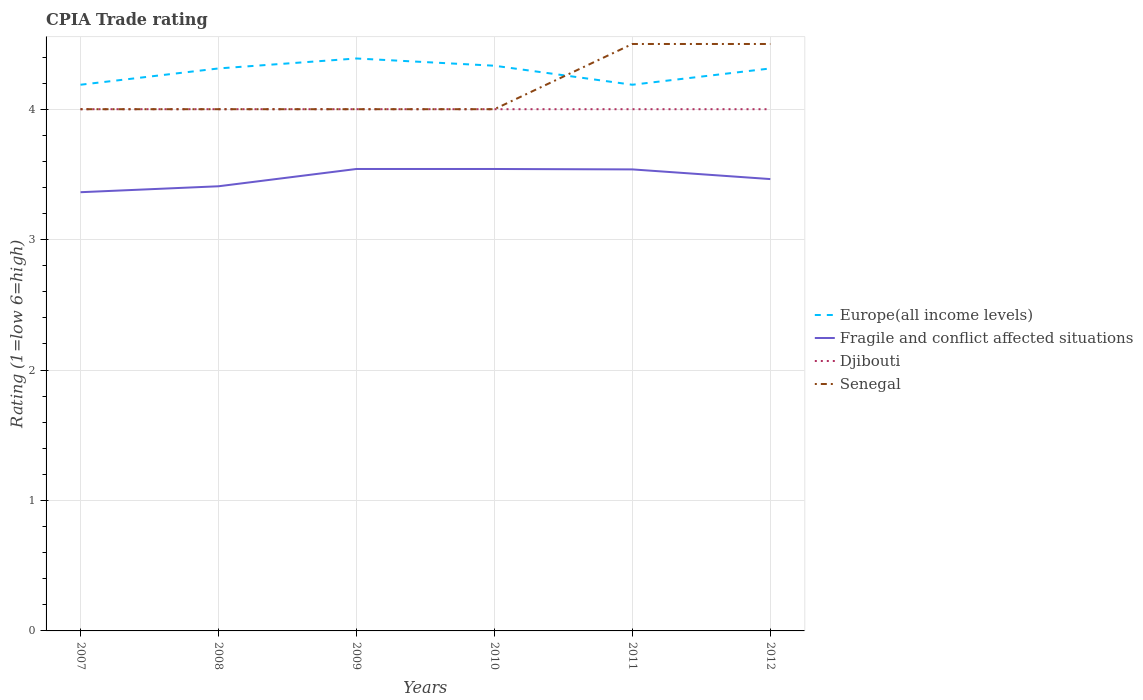How many different coloured lines are there?
Keep it short and to the point. 4. Does the line corresponding to Europe(all income levels) intersect with the line corresponding to Fragile and conflict affected situations?
Ensure brevity in your answer.  No. Is the number of lines equal to the number of legend labels?
Give a very brief answer. Yes. Across all years, what is the maximum CPIA rating in Europe(all income levels)?
Offer a very short reply. 4.19. What is the difference between the highest and the second highest CPIA rating in Fragile and conflict affected situations?
Provide a succinct answer. 0.18. How many lines are there?
Your response must be concise. 4. What is the difference between two consecutive major ticks on the Y-axis?
Your answer should be very brief. 1. Are the values on the major ticks of Y-axis written in scientific E-notation?
Offer a terse response. No. Does the graph contain any zero values?
Your answer should be compact. No. Where does the legend appear in the graph?
Your answer should be compact. Center right. How are the legend labels stacked?
Your answer should be very brief. Vertical. What is the title of the graph?
Offer a very short reply. CPIA Trade rating. Does "Hungary" appear as one of the legend labels in the graph?
Make the answer very short. No. What is the label or title of the X-axis?
Your answer should be compact. Years. What is the Rating (1=low 6=high) of Europe(all income levels) in 2007?
Keep it short and to the point. 4.19. What is the Rating (1=low 6=high) of Fragile and conflict affected situations in 2007?
Ensure brevity in your answer.  3.36. What is the Rating (1=low 6=high) in Djibouti in 2007?
Offer a terse response. 4. What is the Rating (1=low 6=high) of Senegal in 2007?
Keep it short and to the point. 4. What is the Rating (1=low 6=high) in Europe(all income levels) in 2008?
Offer a terse response. 4.31. What is the Rating (1=low 6=high) of Fragile and conflict affected situations in 2008?
Offer a very short reply. 3.41. What is the Rating (1=low 6=high) in Djibouti in 2008?
Your answer should be compact. 4. What is the Rating (1=low 6=high) of Europe(all income levels) in 2009?
Keep it short and to the point. 4.39. What is the Rating (1=low 6=high) of Fragile and conflict affected situations in 2009?
Offer a terse response. 3.54. What is the Rating (1=low 6=high) in Djibouti in 2009?
Your answer should be very brief. 4. What is the Rating (1=low 6=high) in Senegal in 2009?
Provide a short and direct response. 4. What is the Rating (1=low 6=high) of Europe(all income levels) in 2010?
Offer a terse response. 4.33. What is the Rating (1=low 6=high) of Fragile and conflict affected situations in 2010?
Keep it short and to the point. 3.54. What is the Rating (1=low 6=high) of Senegal in 2010?
Keep it short and to the point. 4. What is the Rating (1=low 6=high) of Europe(all income levels) in 2011?
Your response must be concise. 4.19. What is the Rating (1=low 6=high) in Fragile and conflict affected situations in 2011?
Offer a very short reply. 3.54. What is the Rating (1=low 6=high) of Djibouti in 2011?
Offer a very short reply. 4. What is the Rating (1=low 6=high) in Senegal in 2011?
Your answer should be very brief. 4.5. What is the Rating (1=low 6=high) in Europe(all income levels) in 2012?
Offer a very short reply. 4.31. What is the Rating (1=low 6=high) of Fragile and conflict affected situations in 2012?
Your response must be concise. 3.46. What is the Rating (1=low 6=high) of Djibouti in 2012?
Give a very brief answer. 4. What is the Rating (1=low 6=high) of Senegal in 2012?
Provide a succinct answer. 4.5. Across all years, what is the maximum Rating (1=low 6=high) of Europe(all income levels)?
Your response must be concise. 4.39. Across all years, what is the maximum Rating (1=low 6=high) of Fragile and conflict affected situations?
Your answer should be compact. 3.54. Across all years, what is the minimum Rating (1=low 6=high) in Europe(all income levels)?
Your answer should be very brief. 4.19. Across all years, what is the minimum Rating (1=low 6=high) of Fragile and conflict affected situations?
Provide a succinct answer. 3.36. Across all years, what is the minimum Rating (1=low 6=high) in Senegal?
Provide a short and direct response. 4. What is the total Rating (1=low 6=high) of Europe(all income levels) in the graph?
Offer a terse response. 25.72. What is the total Rating (1=low 6=high) in Fragile and conflict affected situations in the graph?
Keep it short and to the point. 20.86. What is the total Rating (1=low 6=high) of Senegal in the graph?
Offer a very short reply. 25. What is the difference between the Rating (1=low 6=high) in Europe(all income levels) in 2007 and that in 2008?
Your answer should be very brief. -0.12. What is the difference between the Rating (1=low 6=high) in Fragile and conflict affected situations in 2007 and that in 2008?
Give a very brief answer. -0.05. What is the difference between the Rating (1=low 6=high) of Djibouti in 2007 and that in 2008?
Offer a very short reply. 0. What is the difference between the Rating (1=low 6=high) of Senegal in 2007 and that in 2008?
Provide a succinct answer. 0. What is the difference between the Rating (1=low 6=high) of Europe(all income levels) in 2007 and that in 2009?
Provide a succinct answer. -0.2. What is the difference between the Rating (1=low 6=high) of Fragile and conflict affected situations in 2007 and that in 2009?
Provide a short and direct response. -0.18. What is the difference between the Rating (1=low 6=high) in Senegal in 2007 and that in 2009?
Offer a terse response. 0. What is the difference between the Rating (1=low 6=high) in Europe(all income levels) in 2007 and that in 2010?
Keep it short and to the point. -0.15. What is the difference between the Rating (1=low 6=high) in Fragile and conflict affected situations in 2007 and that in 2010?
Give a very brief answer. -0.18. What is the difference between the Rating (1=low 6=high) of Europe(all income levels) in 2007 and that in 2011?
Offer a terse response. 0. What is the difference between the Rating (1=low 6=high) in Fragile and conflict affected situations in 2007 and that in 2011?
Offer a terse response. -0.17. What is the difference between the Rating (1=low 6=high) of Djibouti in 2007 and that in 2011?
Your answer should be compact. 0. What is the difference between the Rating (1=low 6=high) in Europe(all income levels) in 2007 and that in 2012?
Your answer should be very brief. -0.12. What is the difference between the Rating (1=low 6=high) in Fragile and conflict affected situations in 2007 and that in 2012?
Your answer should be very brief. -0.1. What is the difference between the Rating (1=low 6=high) of Senegal in 2007 and that in 2012?
Offer a terse response. -0.5. What is the difference between the Rating (1=low 6=high) in Europe(all income levels) in 2008 and that in 2009?
Give a very brief answer. -0.08. What is the difference between the Rating (1=low 6=high) of Fragile and conflict affected situations in 2008 and that in 2009?
Offer a terse response. -0.13. What is the difference between the Rating (1=low 6=high) of Djibouti in 2008 and that in 2009?
Offer a terse response. 0. What is the difference between the Rating (1=low 6=high) in Europe(all income levels) in 2008 and that in 2010?
Make the answer very short. -0.02. What is the difference between the Rating (1=low 6=high) in Fragile and conflict affected situations in 2008 and that in 2010?
Make the answer very short. -0.13. What is the difference between the Rating (1=low 6=high) of Europe(all income levels) in 2008 and that in 2011?
Offer a very short reply. 0.12. What is the difference between the Rating (1=low 6=high) in Fragile and conflict affected situations in 2008 and that in 2011?
Offer a very short reply. -0.13. What is the difference between the Rating (1=low 6=high) of Djibouti in 2008 and that in 2011?
Provide a succinct answer. 0. What is the difference between the Rating (1=low 6=high) of Senegal in 2008 and that in 2011?
Your answer should be compact. -0.5. What is the difference between the Rating (1=low 6=high) of Fragile and conflict affected situations in 2008 and that in 2012?
Ensure brevity in your answer.  -0.06. What is the difference between the Rating (1=low 6=high) of Europe(all income levels) in 2009 and that in 2010?
Offer a very short reply. 0.06. What is the difference between the Rating (1=low 6=high) of Fragile and conflict affected situations in 2009 and that in 2010?
Your response must be concise. 0. What is the difference between the Rating (1=low 6=high) in Europe(all income levels) in 2009 and that in 2011?
Your response must be concise. 0.2. What is the difference between the Rating (1=low 6=high) in Fragile and conflict affected situations in 2009 and that in 2011?
Keep it short and to the point. 0. What is the difference between the Rating (1=low 6=high) of Djibouti in 2009 and that in 2011?
Your response must be concise. 0. What is the difference between the Rating (1=low 6=high) of Senegal in 2009 and that in 2011?
Make the answer very short. -0.5. What is the difference between the Rating (1=low 6=high) of Europe(all income levels) in 2009 and that in 2012?
Your answer should be very brief. 0.08. What is the difference between the Rating (1=low 6=high) in Fragile and conflict affected situations in 2009 and that in 2012?
Your answer should be very brief. 0.08. What is the difference between the Rating (1=low 6=high) of Senegal in 2009 and that in 2012?
Offer a terse response. -0.5. What is the difference between the Rating (1=low 6=high) of Europe(all income levels) in 2010 and that in 2011?
Offer a very short reply. 0.15. What is the difference between the Rating (1=low 6=high) in Fragile and conflict affected situations in 2010 and that in 2011?
Your response must be concise. 0. What is the difference between the Rating (1=low 6=high) in Djibouti in 2010 and that in 2011?
Ensure brevity in your answer.  0. What is the difference between the Rating (1=low 6=high) in Senegal in 2010 and that in 2011?
Your answer should be very brief. -0.5. What is the difference between the Rating (1=low 6=high) of Europe(all income levels) in 2010 and that in 2012?
Provide a succinct answer. 0.02. What is the difference between the Rating (1=low 6=high) of Fragile and conflict affected situations in 2010 and that in 2012?
Provide a short and direct response. 0.08. What is the difference between the Rating (1=low 6=high) in Senegal in 2010 and that in 2012?
Your answer should be compact. -0.5. What is the difference between the Rating (1=low 6=high) in Europe(all income levels) in 2011 and that in 2012?
Make the answer very short. -0.12. What is the difference between the Rating (1=low 6=high) of Fragile and conflict affected situations in 2011 and that in 2012?
Provide a succinct answer. 0.07. What is the difference between the Rating (1=low 6=high) in Djibouti in 2011 and that in 2012?
Give a very brief answer. 0. What is the difference between the Rating (1=low 6=high) in Senegal in 2011 and that in 2012?
Keep it short and to the point. 0. What is the difference between the Rating (1=low 6=high) in Europe(all income levels) in 2007 and the Rating (1=low 6=high) in Fragile and conflict affected situations in 2008?
Keep it short and to the point. 0.78. What is the difference between the Rating (1=low 6=high) of Europe(all income levels) in 2007 and the Rating (1=low 6=high) of Djibouti in 2008?
Offer a terse response. 0.19. What is the difference between the Rating (1=low 6=high) in Europe(all income levels) in 2007 and the Rating (1=low 6=high) in Senegal in 2008?
Keep it short and to the point. 0.19. What is the difference between the Rating (1=low 6=high) in Fragile and conflict affected situations in 2007 and the Rating (1=low 6=high) in Djibouti in 2008?
Provide a short and direct response. -0.64. What is the difference between the Rating (1=low 6=high) of Fragile and conflict affected situations in 2007 and the Rating (1=low 6=high) of Senegal in 2008?
Provide a succinct answer. -0.64. What is the difference between the Rating (1=low 6=high) of Djibouti in 2007 and the Rating (1=low 6=high) of Senegal in 2008?
Offer a terse response. 0. What is the difference between the Rating (1=low 6=high) of Europe(all income levels) in 2007 and the Rating (1=low 6=high) of Fragile and conflict affected situations in 2009?
Your answer should be very brief. 0.65. What is the difference between the Rating (1=low 6=high) of Europe(all income levels) in 2007 and the Rating (1=low 6=high) of Djibouti in 2009?
Your response must be concise. 0.19. What is the difference between the Rating (1=low 6=high) of Europe(all income levels) in 2007 and the Rating (1=low 6=high) of Senegal in 2009?
Keep it short and to the point. 0.19. What is the difference between the Rating (1=low 6=high) in Fragile and conflict affected situations in 2007 and the Rating (1=low 6=high) in Djibouti in 2009?
Your answer should be compact. -0.64. What is the difference between the Rating (1=low 6=high) in Fragile and conflict affected situations in 2007 and the Rating (1=low 6=high) in Senegal in 2009?
Ensure brevity in your answer.  -0.64. What is the difference between the Rating (1=low 6=high) of Europe(all income levels) in 2007 and the Rating (1=low 6=high) of Fragile and conflict affected situations in 2010?
Provide a succinct answer. 0.65. What is the difference between the Rating (1=low 6=high) in Europe(all income levels) in 2007 and the Rating (1=low 6=high) in Djibouti in 2010?
Your answer should be very brief. 0.19. What is the difference between the Rating (1=low 6=high) of Europe(all income levels) in 2007 and the Rating (1=low 6=high) of Senegal in 2010?
Offer a very short reply. 0.19. What is the difference between the Rating (1=low 6=high) of Fragile and conflict affected situations in 2007 and the Rating (1=low 6=high) of Djibouti in 2010?
Ensure brevity in your answer.  -0.64. What is the difference between the Rating (1=low 6=high) in Fragile and conflict affected situations in 2007 and the Rating (1=low 6=high) in Senegal in 2010?
Your answer should be very brief. -0.64. What is the difference between the Rating (1=low 6=high) in Europe(all income levels) in 2007 and the Rating (1=low 6=high) in Fragile and conflict affected situations in 2011?
Provide a short and direct response. 0.65. What is the difference between the Rating (1=low 6=high) of Europe(all income levels) in 2007 and the Rating (1=low 6=high) of Djibouti in 2011?
Give a very brief answer. 0.19. What is the difference between the Rating (1=low 6=high) of Europe(all income levels) in 2007 and the Rating (1=low 6=high) of Senegal in 2011?
Make the answer very short. -0.31. What is the difference between the Rating (1=low 6=high) of Fragile and conflict affected situations in 2007 and the Rating (1=low 6=high) of Djibouti in 2011?
Your answer should be compact. -0.64. What is the difference between the Rating (1=low 6=high) of Fragile and conflict affected situations in 2007 and the Rating (1=low 6=high) of Senegal in 2011?
Your answer should be compact. -1.14. What is the difference between the Rating (1=low 6=high) of Djibouti in 2007 and the Rating (1=low 6=high) of Senegal in 2011?
Provide a short and direct response. -0.5. What is the difference between the Rating (1=low 6=high) of Europe(all income levels) in 2007 and the Rating (1=low 6=high) of Fragile and conflict affected situations in 2012?
Offer a very short reply. 0.72. What is the difference between the Rating (1=low 6=high) in Europe(all income levels) in 2007 and the Rating (1=low 6=high) in Djibouti in 2012?
Your answer should be compact. 0.19. What is the difference between the Rating (1=low 6=high) in Europe(all income levels) in 2007 and the Rating (1=low 6=high) in Senegal in 2012?
Keep it short and to the point. -0.31. What is the difference between the Rating (1=low 6=high) in Fragile and conflict affected situations in 2007 and the Rating (1=low 6=high) in Djibouti in 2012?
Ensure brevity in your answer.  -0.64. What is the difference between the Rating (1=low 6=high) of Fragile and conflict affected situations in 2007 and the Rating (1=low 6=high) of Senegal in 2012?
Your answer should be compact. -1.14. What is the difference between the Rating (1=low 6=high) in Djibouti in 2007 and the Rating (1=low 6=high) in Senegal in 2012?
Your response must be concise. -0.5. What is the difference between the Rating (1=low 6=high) of Europe(all income levels) in 2008 and the Rating (1=low 6=high) of Fragile and conflict affected situations in 2009?
Your response must be concise. 0.77. What is the difference between the Rating (1=low 6=high) of Europe(all income levels) in 2008 and the Rating (1=low 6=high) of Djibouti in 2009?
Make the answer very short. 0.31. What is the difference between the Rating (1=low 6=high) of Europe(all income levels) in 2008 and the Rating (1=low 6=high) of Senegal in 2009?
Provide a short and direct response. 0.31. What is the difference between the Rating (1=low 6=high) of Fragile and conflict affected situations in 2008 and the Rating (1=low 6=high) of Djibouti in 2009?
Your response must be concise. -0.59. What is the difference between the Rating (1=low 6=high) of Fragile and conflict affected situations in 2008 and the Rating (1=low 6=high) of Senegal in 2009?
Keep it short and to the point. -0.59. What is the difference between the Rating (1=low 6=high) in Europe(all income levels) in 2008 and the Rating (1=low 6=high) in Fragile and conflict affected situations in 2010?
Your answer should be compact. 0.77. What is the difference between the Rating (1=low 6=high) of Europe(all income levels) in 2008 and the Rating (1=low 6=high) of Djibouti in 2010?
Give a very brief answer. 0.31. What is the difference between the Rating (1=low 6=high) of Europe(all income levels) in 2008 and the Rating (1=low 6=high) of Senegal in 2010?
Offer a very short reply. 0.31. What is the difference between the Rating (1=low 6=high) in Fragile and conflict affected situations in 2008 and the Rating (1=low 6=high) in Djibouti in 2010?
Offer a terse response. -0.59. What is the difference between the Rating (1=low 6=high) of Fragile and conflict affected situations in 2008 and the Rating (1=low 6=high) of Senegal in 2010?
Offer a very short reply. -0.59. What is the difference between the Rating (1=low 6=high) of Europe(all income levels) in 2008 and the Rating (1=low 6=high) of Fragile and conflict affected situations in 2011?
Offer a terse response. 0.77. What is the difference between the Rating (1=low 6=high) of Europe(all income levels) in 2008 and the Rating (1=low 6=high) of Djibouti in 2011?
Provide a succinct answer. 0.31. What is the difference between the Rating (1=low 6=high) of Europe(all income levels) in 2008 and the Rating (1=low 6=high) of Senegal in 2011?
Make the answer very short. -0.19. What is the difference between the Rating (1=low 6=high) of Fragile and conflict affected situations in 2008 and the Rating (1=low 6=high) of Djibouti in 2011?
Give a very brief answer. -0.59. What is the difference between the Rating (1=low 6=high) of Fragile and conflict affected situations in 2008 and the Rating (1=low 6=high) of Senegal in 2011?
Your response must be concise. -1.09. What is the difference between the Rating (1=low 6=high) of Djibouti in 2008 and the Rating (1=low 6=high) of Senegal in 2011?
Keep it short and to the point. -0.5. What is the difference between the Rating (1=low 6=high) in Europe(all income levels) in 2008 and the Rating (1=low 6=high) in Fragile and conflict affected situations in 2012?
Keep it short and to the point. 0.85. What is the difference between the Rating (1=low 6=high) of Europe(all income levels) in 2008 and the Rating (1=low 6=high) of Djibouti in 2012?
Keep it short and to the point. 0.31. What is the difference between the Rating (1=low 6=high) in Europe(all income levels) in 2008 and the Rating (1=low 6=high) in Senegal in 2012?
Your answer should be very brief. -0.19. What is the difference between the Rating (1=low 6=high) of Fragile and conflict affected situations in 2008 and the Rating (1=low 6=high) of Djibouti in 2012?
Keep it short and to the point. -0.59. What is the difference between the Rating (1=low 6=high) in Fragile and conflict affected situations in 2008 and the Rating (1=low 6=high) in Senegal in 2012?
Keep it short and to the point. -1.09. What is the difference between the Rating (1=low 6=high) of Djibouti in 2008 and the Rating (1=low 6=high) of Senegal in 2012?
Your response must be concise. -0.5. What is the difference between the Rating (1=low 6=high) in Europe(all income levels) in 2009 and the Rating (1=low 6=high) in Fragile and conflict affected situations in 2010?
Provide a succinct answer. 0.85. What is the difference between the Rating (1=low 6=high) in Europe(all income levels) in 2009 and the Rating (1=low 6=high) in Djibouti in 2010?
Offer a very short reply. 0.39. What is the difference between the Rating (1=low 6=high) in Europe(all income levels) in 2009 and the Rating (1=low 6=high) in Senegal in 2010?
Your answer should be very brief. 0.39. What is the difference between the Rating (1=low 6=high) in Fragile and conflict affected situations in 2009 and the Rating (1=low 6=high) in Djibouti in 2010?
Your answer should be very brief. -0.46. What is the difference between the Rating (1=low 6=high) in Fragile and conflict affected situations in 2009 and the Rating (1=low 6=high) in Senegal in 2010?
Offer a very short reply. -0.46. What is the difference between the Rating (1=low 6=high) in Europe(all income levels) in 2009 and the Rating (1=low 6=high) in Fragile and conflict affected situations in 2011?
Make the answer very short. 0.85. What is the difference between the Rating (1=low 6=high) in Europe(all income levels) in 2009 and the Rating (1=low 6=high) in Djibouti in 2011?
Ensure brevity in your answer.  0.39. What is the difference between the Rating (1=low 6=high) of Europe(all income levels) in 2009 and the Rating (1=low 6=high) of Senegal in 2011?
Provide a short and direct response. -0.11. What is the difference between the Rating (1=low 6=high) in Fragile and conflict affected situations in 2009 and the Rating (1=low 6=high) in Djibouti in 2011?
Keep it short and to the point. -0.46. What is the difference between the Rating (1=low 6=high) in Fragile and conflict affected situations in 2009 and the Rating (1=low 6=high) in Senegal in 2011?
Offer a terse response. -0.96. What is the difference between the Rating (1=low 6=high) in Europe(all income levels) in 2009 and the Rating (1=low 6=high) in Fragile and conflict affected situations in 2012?
Your answer should be compact. 0.92. What is the difference between the Rating (1=low 6=high) of Europe(all income levels) in 2009 and the Rating (1=low 6=high) of Djibouti in 2012?
Give a very brief answer. 0.39. What is the difference between the Rating (1=low 6=high) of Europe(all income levels) in 2009 and the Rating (1=low 6=high) of Senegal in 2012?
Ensure brevity in your answer.  -0.11. What is the difference between the Rating (1=low 6=high) in Fragile and conflict affected situations in 2009 and the Rating (1=low 6=high) in Djibouti in 2012?
Ensure brevity in your answer.  -0.46. What is the difference between the Rating (1=low 6=high) in Fragile and conflict affected situations in 2009 and the Rating (1=low 6=high) in Senegal in 2012?
Offer a terse response. -0.96. What is the difference between the Rating (1=low 6=high) in Europe(all income levels) in 2010 and the Rating (1=low 6=high) in Fragile and conflict affected situations in 2011?
Make the answer very short. 0.79. What is the difference between the Rating (1=low 6=high) in Fragile and conflict affected situations in 2010 and the Rating (1=low 6=high) in Djibouti in 2011?
Make the answer very short. -0.46. What is the difference between the Rating (1=low 6=high) in Fragile and conflict affected situations in 2010 and the Rating (1=low 6=high) in Senegal in 2011?
Provide a succinct answer. -0.96. What is the difference between the Rating (1=low 6=high) in Europe(all income levels) in 2010 and the Rating (1=low 6=high) in Fragile and conflict affected situations in 2012?
Keep it short and to the point. 0.87. What is the difference between the Rating (1=low 6=high) of Europe(all income levels) in 2010 and the Rating (1=low 6=high) of Djibouti in 2012?
Provide a short and direct response. 0.33. What is the difference between the Rating (1=low 6=high) of Europe(all income levels) in 2010 and the Rating (1=low 6=high) of Senegal in 2012?
Offer a terse response. -0.17. What is the difference between the Rating (1=low 6=high) in Fragile and conflict affected situations in 2010 and the Rating (1=low 6=high) in Djibouti in 2012?
Your answer should be very brief. -0.46. What is the difference between the Rating (1=low 6=high) of Fragile and conflict affected situations in 2010 and the Rating (1=low 6=high) of Senegal in 2012?
Your answer should be compact. -0.96. What is the difference between the Rating (1=low 6=high) in Europe(all income levels) in 2011 and the Rating (1=low 6=high) in Fragile and conflict affected situations in 2012?
Your answer should be compact. 0.72. What is the difference between the Rating (1=low 6=high) in Europe(all income levels) in 2011 and the Rating (1=low 6=high) in Djibouti in 2012?
Offer a terse response. 0.19. What is the difference between the Rating (1=low 6=high) of Europe(all income levels) in 2011 and the Rating (1=low 6=high) of Senegal in 2012?
Provide a succinct answer. -0.31. What is the difference between the Rating (1=low 6=high) of Fragile and conflict affected situations in 2011 and the Rating (1=low 6=high) of Djibouti in 2012?
Give a very brief answer. -0.46. What is the difference between the Rating (1=low 6=high) of Fragile and conflict affected situations in 2011 and the Rating (1=low 6=high) of Senegal in 2012?
Offer a terse response. -0.96. What is the average Rating (1=low 6=high) in Europe(all income levels) per year?
Your response must be concise. 4.29. What is the average Rating (1=low 6=high) of Fragile and conflict affected situations per year?
Your answer should be compact. 3.48. What is the average Rating (1=low 6=high) of Senegal per year?
Ensure brevity in your answer.  4.17. In the year 2007, what is the difference between the Rating (1=low 6=high) in Europe(all income levels) and Rating (1=low 6=high) in Fragile and conflict affected situations?
Your answer should be very brief. 0.82. In the year 2007, what is the difference between the Rating (1=low 6=high) in Europe(all income levels) and Rating (1=low 6=high) in Djibouti?
Your answer should be compact. 0.19. In the year 2007, what is the difference between the Rating (1=low 6=high) in Europe(all income levels) and Rating (1=low 6=high) in Senegal?
Offer a very short reply. 0.19. In the year 2007, what is the difference between the Rating (1=low 6=high) in Fragile and conflict affected situations and Rating (1=low 6=high) in Djibouti?
Your response must be concise. -0.64. In the year 2007, what is the difference between the Rating (1=low 6=high) in Fragile and conflict affected situations and Rating (1=low 6=high) in Senegal?
Provide a succinct answer. -0.64. In the year 2007, what is the difference between the Rating (1=low 6=high) in Djibouti and Rating (1=low 6=high) in Senegal?
Your answer should be compact. 0. In the year 2008, what is the difference between the Rating (1=low 6=high) in Europe(all income levels) and Rating (1=low 6=high) in Fragile and conflict affected situations?
Your answer should be compact. 0.9. In the year 2008, what is the difference between the Rating (1=low 6=high) in Europe(all income levels) and Rating (1=low 6=high) in Djibouti?
Ensure brevity in your answer.  0.31. In the year 2008, what is the difference between the Rating (1=low 6=high) in Europe(all income levels) and Rating (1=low 6=high) in Senegal?
Your answer should be compact. 0.31. In the year 2008, what is the difference between the Rating (1=low 6=high) of Fragile and conflict affected situations and Rating (1=low 6=high) of Djibouti?
Provide a succinct answer. -0.59. In the year 2008, what is the difference between the Rating (1=low 6=high) in Fragile and conflict affected situations and Rating (1=low 6=high) in Senegal?
Offer a very short reply. -0.59. In the year 2009, what is the difference between the Rating (1=low 6=high) in Europe(all income levels) and Rating (1=low 6=high) in Fragile and conflict affected situations?
Ensure brevity in your answer.  0.85. In the year 2009, what is the difference between the Rating (1=low 6=high) in Europe(all income levels) and Rating (1=low 6=high) in Djibouti?
Your answer should be very brief. 0.39. In the year 2009, what is the difference between the Rating (1=low 6=high) in Europe(all income levels) and Rating (1=low 6=high) in Senegal?
Provide a succinct answer. 0.39. In the year 2009, what is the difference between the Rating (1=low 6=high) in Fragile and conflict affected situations and Rating (1=low 6=high) in Djibouti?
Offer a very short reply. -0.46. In the year 2009, what is the difference between the Rating (1=low 6=high) in Fragile and conflict affected situations and Rating (1=low 6=high) in Senegal?
Offer a very short reply. -0.46. In the year 2010, what is the difference between the Rating (1=low 6=high) of Europe(all income levels) and Rating (1=low 6=high) of Fragile and conflict affected situations?
Your response must be concise. 0.79. In the year 2010, what is the difference between the Rating (1=low 6=high) in Fragile and conflict affected situations and Rating (1=low 6=high) in Djibouti?
Offer a terse response. -0.46. In the year 2010, what is the difference between the Rating (1=low 6=high) of Fragile and conflict affected situations and Rating (1=low 6=high) of Senegal?
Your answer should be compact. -0.46. In the year 2010, what is the difference between the Rating (1=low 6=high) of Djibouti and Rating (1=low 6=high) of Senegal?
Offer a terse response. 0. In the year 2011, what is the difference between the Rating (1=low 6=high) in Europe(all income levels) and Rating (1=low 6=high) in Fragile and conflict affected situations?
Keep it short and to the point. 0.65. In the year 2011, what is the difference between the Rating (1=low 6=high) in Europe(all income levels) and Rating (1=low 6=high) in Djibouti?
Offer a terse response. 0.19. In the year 2011, what is the difference between the Rating (1=low 6=high) in Europe(all income levels) and Rating (1=low 6=high) in Senegal?
Your response must be concise. -0.31. In the year 2011, what is the difference between the Rating (1=low 6=high) in Fragile and conflict affected situations and Rating (1=low 6=high) in Djibouti?
Your answer should be very brief. -0.46. In the year 2011, what is the difference between the Rating (1=low 6=high) in Fragile and conflict affected situations and Rating (1=low 6=high) in Senegal?
Provide a short and direct response. -0.96. In the year 2012, what is the difference between the Rating (1=low 6=high) of Europe(all income levels) and Rating (1=low 6=high) of Fragile and conflict affected situations?
Make the answer very short. 0.85. In the year 2012, what is the difference between the Rating (1=low 6=high) in Europe(all income levels) and Rating (1=low 6=high) in Djibouti?
Your answer should be very brief. 0.31. In the year 2012, what is the difference between the Rating (1=low 6=high) in Europe(all income levels) and Rating (1=low 6=high) in Senegal?
Your answer should be compact. -0.19. In the year 2012, what is the difference between the Rating (1=low 6=high) of Fragile and conflict affected situations and Rating (1=low 6=high) of Djibouti?
Your response must be concise. -0.54. In the year 2012, what is the difference between the Rating (1=low 6=high) of Fragile and conflict affected situations and Rating (1=low 6=high) of Senegal?
Make the answer very short. -1.04. What is the ratio of the Rating (1=low 6=high) in Fragile and conflict affected situations in 2007 to that in 2008?
Your answer should be compact. 0.99. What is the ratio of the Rating (1=low 6=high) in Senegal in 2007 to that in 2008?
Offer a very short reply. 1. What is the ratio of the Rating (1=low 6=high) of Europe(all income levels) in 2007 to that in 2009?
Make the answer very short. 0.95. What is the ratio of the Rating (1=low 6=high) of Fragile and conflict affected situations in 2007 to that in 2009?
Make the answer very short. 0.95. What is the ratio of the Rating (1=low 6=high) in Djibouti in 2007 to that in 2009?
Give a very brief answer. 1. What is the ratio of the Rating (1=low 6=high) in Senegal in 2007 to that in 2009?
Make the answer very short. 1. What is the ratio of the Rating (1=low 6=high) in Europe(all income levels) in 2007 to that in 2010?
Your response must be concise. 0.97. What is the ratio of the Rating (1=low 6=high) in Fragile and conflict affected situations in 2007 to that in 2010?
Your answer should be compact. 0.95. What is the ratio of the Rating (1=low 6=high) in Djibouti in 2007 to that in 2010?
Keep it short and to the point. 1. What is the ratio of the Rating (1=low 6=high) in Senegal in 2007 to that in 2010?
Offer a terse response. 1. What is the ratio of the Rating (1=low 6=high) in Fragile and conflict affected situations in 2007 to that in 2011?
Ensure brevity in your answer.  0.95. What is the ratio of the Rating (1=low 6=high) in Djibouti in 2007 to that in 2011?
Your answer should be compact. 1. What is the ratio of the Rating (1=low 6=high) of Senegal in 2007 to that in 2011?
Your response must be concise. 0.89. What is the ratio of the Rating (1=low 6=high) of Fragile and conflict affected situations in 2007 to that in 2012?
Make the answer very short. 0.97. What is the ratio of the Rating (1=low 6=high) in Djibouti in 2007 to that in 2012?
Give a very brief answer. 1. What is the ratio of the Rating (1=low 6=high) in Senegal in 2007 to that in 2012?
Offer a terse response. 0.89. What is the ratio of the Rating (1=low 6=high) in Europe(all income levels) in 2008 to that in 2009?
Offer a terse response. 0.98. What is the ratio of the Rating (1=low 6=high) of Fragile and conflict affected situations in 2008 to that in 2009?
Offer a very short reply. 0.96. What is the ratio of the Rating (1=low 6=high) in Djibouti in 2008 to that in 2009?
Your answer should be compact. 1. What is the ratio of the Rating (1=low 6=high) of Fragile and conflict affected situations in 2008 to that in 2010?
Provide a succinct answer. 0.96. What is the ratio of the Rating (1=low 6=high) of Europe(all income levels) in 2008 to that in 2011?
Offer a very short reply. 1.03. What is the ratio of the Rating (1=low 6=high) in Fragile and conflict affected situations in 2008 to that in 2011?
Ensure brevity in your answer.  0.96. What is the ratio of the Rating (1=low 6=high) of Djibouti in 2008 to that in 2011?
Give a very brief answer. 1. What is the ratio of the Rating (1=low 6=high) in Senegal in 2008 to that in 2011?
Your answer should be very brief. 0.89. What is the ratio of the Rating (1=low 6=high) in Europe(all income levels) in 2008 to that in 2012?
Your answer should be compact. 1. What is the ratio of the Rating (1=low 6=high) in Fragile and conflict affected situations in 2008 to that in 2012?
Offer a very short reply. 0.98. What is the ratio of the Rating (1=low 6=high) of Senegal in 2008 to that in 2012?
Provide a short and direct response. 0.89. What is the ratio of the Rating (1=low 6=high) of Europe(all income levels) in 2009 to that in 2010?
Ensure brevity in your answer.  1.01. What is the ratio of the Rating (1=low 6=high) in Europe(all income levels) in 2009 to that in 2011?
Offer a very short reply. 1.05. What is the ratio of the Rating (1=low 6=high) in Fragile and conflict affected situations in 2009 to that in 2011?
Keep it short and to the point. 1. What is the ratio of the Rating (1=low 6=high) in Europe(all income levels) in 2009 to that in 2012?
Give a very brief answer. 1.02. What is the ratio of the Rating (1=low 6=high) of Fragile and conflict affected situations in 2009 to that in 2012?
Your answer should be compact. 1.02. What is the ratio of the Rating (1=low 6=high) of Senegal in 2009 to that in 2012?
Provide a short and direct response. 0.89. What is the ratio of the Rating (1=low 6=high) in Europe(all income levels) in 2010 to that in 2011?
Your answer should be compact. 1.03. What is the ratio of the Rating (1=low 6=high) in Senegal in 2010 to that in 2011?
Provide a short and direct response. 0.89. What is the ratio of the Rating (1=low 6=high) of Europe(all income levels) in 2010 to that in 2012?
Your answer should be very brief. 1. What is the ratio of the Rating (1=low 6=high) of Fragile and conflict affected situations in 2010 to that in 2012?
Offer a terse response. 1.02. What is the ratio of the Rating (1=low 6=high) of Djibouti in 2010 to that in 2012?
Offer a very short reply. 1. What is the ratio of the Rating (1=low 6=high) of Fragile and conflict affected situations in 2011 to that in 2012?
Give a very brief answer. 1.02. What is the ratio of the Rating (1=low 6=high) in Djibouti in 2011 to that in 2012?
Your answer should be very brief. 1. What is the difference between the highest and the second highest Rating (1=low 6=high) of Europe(all income levels)?
Make the answer very short. 0.06. What is the difference between the highest and the second highest Rating (1=low 6=high) of Djibouti?
Your response must be concise. 0. What is the difference between the highest and the lowest Rating (1=low 6=high) in Europe(all income levels)?
Keep it short and to the point. 0.2. What is the difference between the highest and the lowest Rating (1=low 6=high) in Fragile and conflict affected situations?
Offer a very short reply. 0.18. What is the difference between the highest and the lowest Rating (1=low 6=high) in Senegal?
Your answer should be very brief. 0.5. 